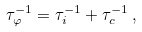<formula> <loc_0><loc_0><loc_500><loc_500>\tau _ { \varphi } ^ { - 1 } = \tau _ { i } ^ { - 1 } + \tau _ { c } ^ { - 1 } \, ,</formula> 